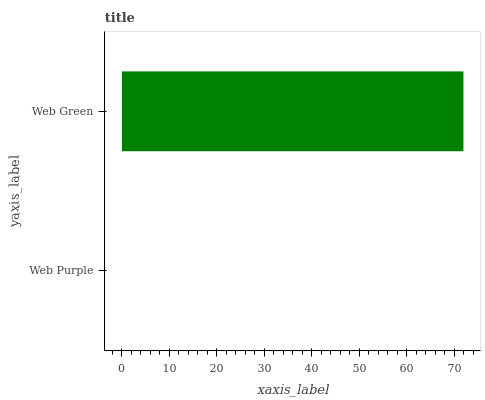Is Web Purple the minimum?
Answer yes or no. Yes. Is Web Green the maximum?
Answer yes or no. Yes. Is Web Green the minimum?
Answer yes or no. No. Is Web Green greater than Web Purple?
Answer yes or no. Yes. Is Web Purple less than Web Green?
Answer yes or no. Yes. Is Web Purple greater than Web Green?
Answer yes or no. No. Is Web Green less than Web Purple?
Answer yes or no. No. Is Web Green the high median?
Answer yes or no. Yes. Is Web Purple the low median?
Answer yes or no. Yes. Is Web Purple the high median?
Answer yes or no. No. Is Web Green the low median?
Answer yes or no. No. 